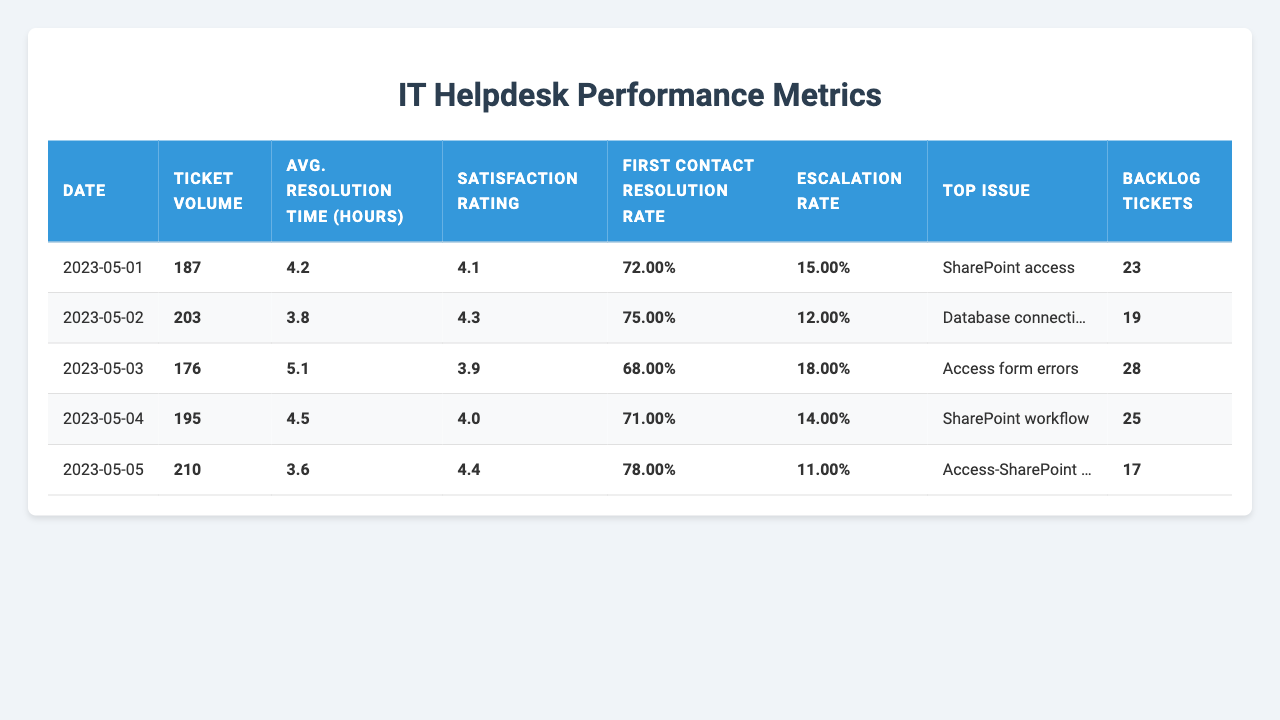What was the ticket volume on May 02, 2023? According to the table, the ticket volume for May 02, 2023, is directly listed under the "Ticket Volume" column for that date, which shows 203 tickets.
Answer: 203 What was the average resolution time on May 03, 2023? The average resolution time for May 03, 2023, can be found in the "Avg. Resolution Time (hours)" column, which lists it as 5.1 hours.
Answer: 5.1 hours Which date had the highest satisfaction rating? Looking through the "Satisfaction Rating" column, the date with the highest score is May 05, 2023, at 4.4, which is greater than the ratings on other days.
Answer: May 05, 2023 What is the average first contact resolution rate for the provided data? To find this average, we sum the first contact resolution rates (0.72 + 0.75 + 0.68 + 0.71 + 0.78 = 3.64) and divide by the number of days (5): 3.64 / 5 = 0.728.
Answer: 72.8% How many total tickets were opened from May 01 to May 05, 2023? We add up the ticket volumes across these days: 187 + 203 + 176 + 195 + 210 = 971.
Answer: 971 Was the escalation rate on May 05, 2023, lower than the rate on May 01, 2023? Comparing the escalation rates, May 05 has a rate of 0.11 (11%) while May 01 has a rate of 0.15 (15%), and since 0.11 is lower than 0.15, the statement is true.
Answer: Yes How many backlog tickets were reported on May 04, 2023? The backlog tickets for May 04, 2023, are listed in the "Backlog Tickets" column, which states there were 25 tickets.
Answer: 25 What trend can be seen regarding satisfaction ratings over the five days? The satisfaction ratings show fluctuations, starting at 4.1, increasing to 4.3, dropping to 3.9, then rising to 4.0, and finally reaching 4.4 on the last day, indicating variability in user satisfaction.
Answer: Fluctuating trend What is the percentage increase in ticket volume from May 01 to May 05, 2023? We calculate the increase by taking the difference in ticket volumes (210 - 187 = 23), then we find the percentage using the formula (23 / 187) * 100 ≈ 12.28%.
Answer: Approximately 12.3% On which day was "Access form errors" the top issue reported? Referring to the "Top Issue" column for each date, it is shown that "Access form errors" was the top issue on May 03, 2023.
Answer: May 03, 2023 What was the average backlog of tickets during this period? To find the average backlog, sum the backlog tickets (23 + 19 + 28 + 25 + 17 = 112) and divide by the number of days (5): 112 / 5 = 22.4.
Answer: 22.4 tickets 